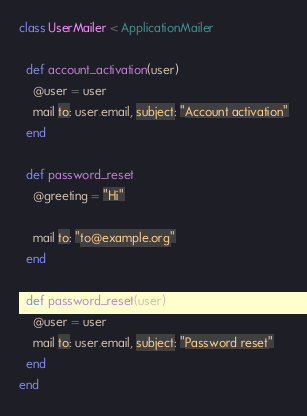Convert code to text. <code><loc_0><loc_0><loc_500><loc_500><_Ruby_>class UserMailer < ApplicationMailer

  def account_activation(user)
    @user = user
    mail to: user.email, subject: "Account activation"
  end

  def password_reset
    @greeting = "Hi"
    
    mail to: "to@example.org"
  end
  
  def password_reset(user)
    @user = user
    mail to: user.email, subject: "Password reset"
  end
end
</code> 